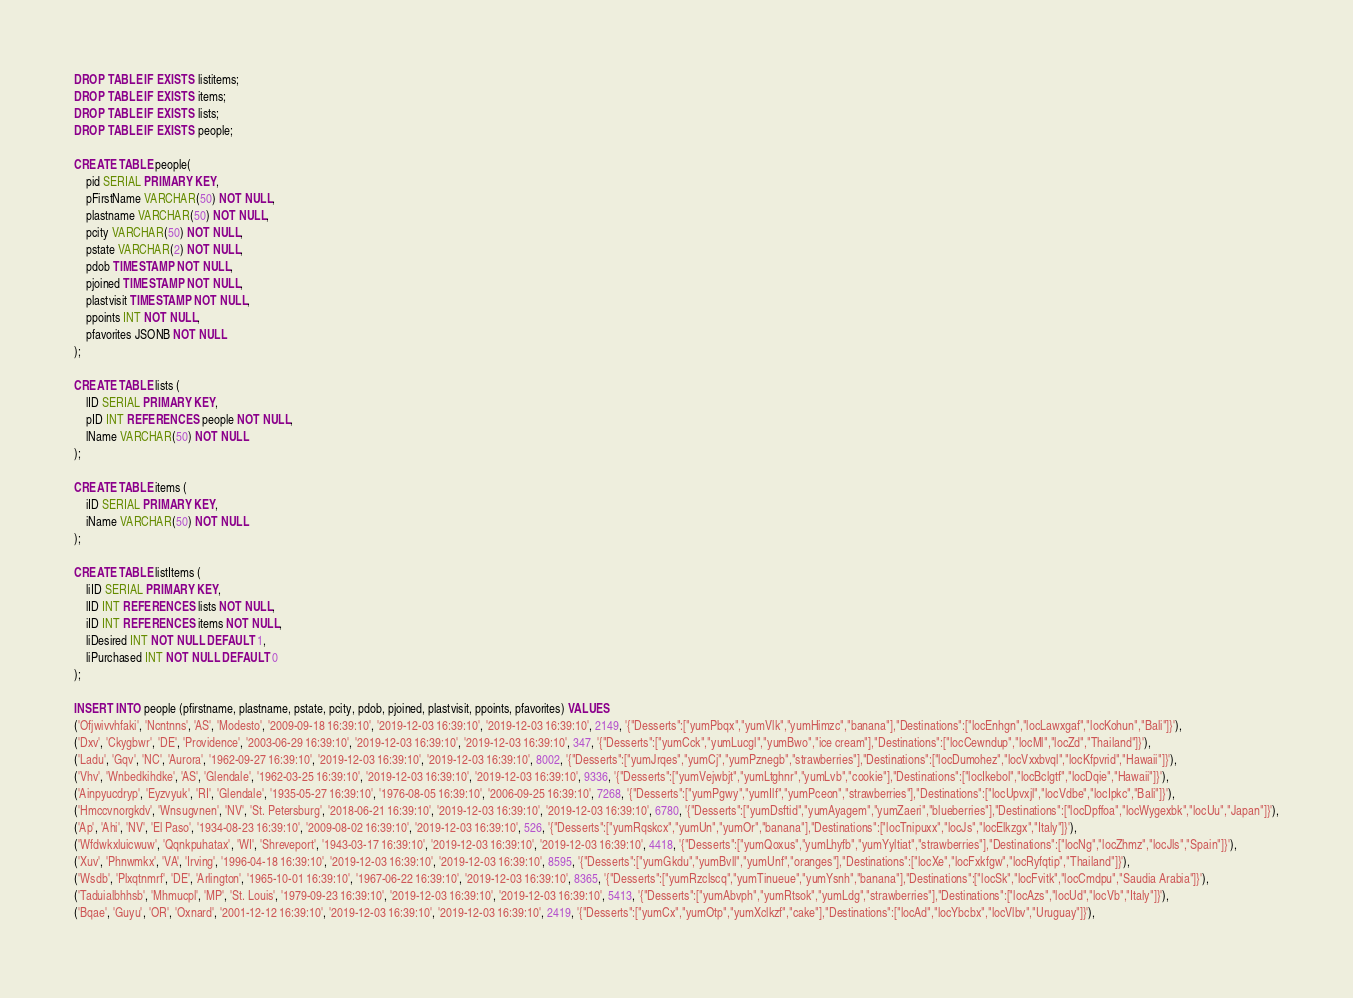<code> <loc_0><loc_0><loc_500><loc_500><_SQL_>DROP TABLE IF EXISTS listitems;
DROP TABLE IF EXISTS items;
DROP TABLE IF EXISTS lists;
DROP TABLE IF EXISTS people;

CREATE TABLE people( 
    pid SERIAL PRIMARY KEY,
    pFirstName VARCHAR(50) NOT NULL,
    plastname VARCHAR(50) NOT NULL,
    pcity VARCHAR(50) NOT NULL,
    pstate VARCHAR(2) NOT NULL,
    pdob TIMESTAMP NOT NULL,
    pjoined TIMESTAMP NOT NULL,
    plastvisit TIMESTAMP NOT NULL,
    ppoints INT NOT NULL,
    pfavorites JSONB NOT NULL
);

CREATE TABLE lists (
    lID SERIAL PRIMARY KEY,
    pID INT REFERENCES people NOT NULL,
    lName VARCHAR(50) NOT NULL
);

CREATE TABLE items (
    iID SERIAL PRIMARY KEY,
    iName VARCHAR(50) NOT NULL
);

CREATE TABLE listItems (
    liID SERIAL PRIMARY KEY,
    lID INT REFERENCES lists NOT NULL,
    iID INT REFERENCES items NOT NULL,
    liDesired INT NOT NULL DEFAULT 1,
    liPurchased INT NOT NULL DEFAULT 0
);

INSERT INTO people (pfirstname, plastname, pstate, pcity, pdob, pjoined, plastvisit, ppoints, pfavorites) VALUES
('Ofjwivvhfaki', 'Ncntnns', 'AS', 'Modesto', '2009-09-18 16:39:10', '2019-12-03 16:39:10', '2019-12-03 16:39:10', 2149, '{"Desserts":["yumPbqx","yumVlk","yumHimzc","banana"],"Destinations":["locEnhgn","locLawxgaf","locKohun","Bali"]}'),
('Dxv', 'Ckygbwr', 'DE', 'Providence', '2003-06-29 16:39:10', '2019-12-03 16:39:10', '2019-12-03 16:39:10', 347, '{"Desserts":["yumCck","yumLucgl","yumBwo","ice cream"],"Destinations":["locCewndup","locMl","locZd","Thailand"]}'),
('Ladu', 'Gqv', 'NC', 'Aurora', '1962-09-27 16:39:10', '2019-12-03 16:39:10', '2019-12-03 16:39:10', 8002, '{"Desserts":["yumJrqes","yumCj","yumPznegb","strawberries"],"Destinations":["locDumohez","locVxxbvql","locKfpvrid","Hawaii"]}'),
('Vhv', 'Wnbedkihdke', 'AS', 'Glendale', '1962-03-25 16:39:10', '2019-12-03 16:39:10', '2019-12-03 16:39:10', 9336, '{"Desserts":["yumVejwbjt","yumLtghnr","yumLvb","cookie"],"Destinations":["locIkebol","locBclgtf","locDqie","Hawaii"]}'),
('Ainpyucdryp', 'Eyzvyuk', 'RI', 'Glendale', '1935-05-27 16:39:10', '1976-08-05 16:39:10', '2006-09-25 16:39:10', 7268, '{"Desserts":["yumPgwy","yumIlf","yumPceon","strawberries"],"Destinations":["locUpvxjl","locVdbe","locIpkc","Bali"]}'),
('Hmccvnorgkdv', 'Wnsugvnen', 'NV', 'St. Petersburg', '2018-06-21 16:39:10', '2019-12-03 16:39:10', '2019-12-03 16:39:10', 6780, '{"Desserts":["yumDsftid","yumAyagem","yumZaeri","blueberries"],"Destinations":["locDpffoa","locWygexbk","locUu","Japan"]}'),
('Ap', 'Ahi', 'NV', 'El Paso', '1934-08-23 16:39:10', '2009-08-02 16:39:10', '2019-12-03 16:39:10', 526, '{"Desserts":["yumRqskcx","yumUn","yumOr","banana"],"Destinations":["locTnipuxx","locJs","locElkzgx","Italy"]}'),
('Wfdwkxluicwuw', 'Qqnkpuhatax', 'WI', 'Shreveport', '1943-03-17 16:39:10', '2019-12-03 16:39:10', '2019-12-03 16:39:10', 4418, '{"Desserts":["yumQoxus","yumLhyfb","yumYyltiat","strawberries"],"Destinations":["locNg","locZhmz","locJls","Spain"]}'),
('Xuv', 'Phnwmkx', 'VA', 'Irving', '1996-04-18 16:39:10', '2019-12-03 16:39:10', '2019-12-03 16:39:10', 8595, '{"Desserts":["yumGkdu","yumBvll","yumUnf","oranges"],"Destinations":["locXe","locFxkfgw","locRyfqtip","Thailand"]}'),
('Wsdb', 'Plxqtnmrf', 'DE', 'Arlington', '1965-10-01 16:39:10', '1967-06-22 16:39:10', '2019-12-03 16:39:10', 8365, '{"Desserts":["yumRzclscq","yumTinueue","yumYsnh","banana"],"Destinations":["locSk","locFvitk","locCmdpu","Saudia Arabia"]}'),
('Taduialbhhsb', 'Mhmucpl', 'MP', 'St. Louis', '1979-09-23 16:39:10', '2019-12-03 16:39:10', '2019-12-03 16:39:10', 5413, '{"Desserts":["yumAbvph","yumRtsok","yumLdg","strawberries"],"Destinations":["locAzs","locUd","locVb","Italy"]}'),
('Bqae', 'Guyu', 'OR', 'Oxnard', '2001-12-12 16:39:10', '2019-12-03 16:39:10', '2019-12-03 16:39:10', 2419, '{"Desserts":["yumCx","yumOtp","yumXclkzf","cake"],"Destinations":["locAd","locYbcbx","locVlbv","Uruguay"]}'),</code> 